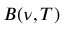Convert formula to latex. <formula><loc_0><loc_0><loc_500><loc_500>B ( \nu , T )</formula> 